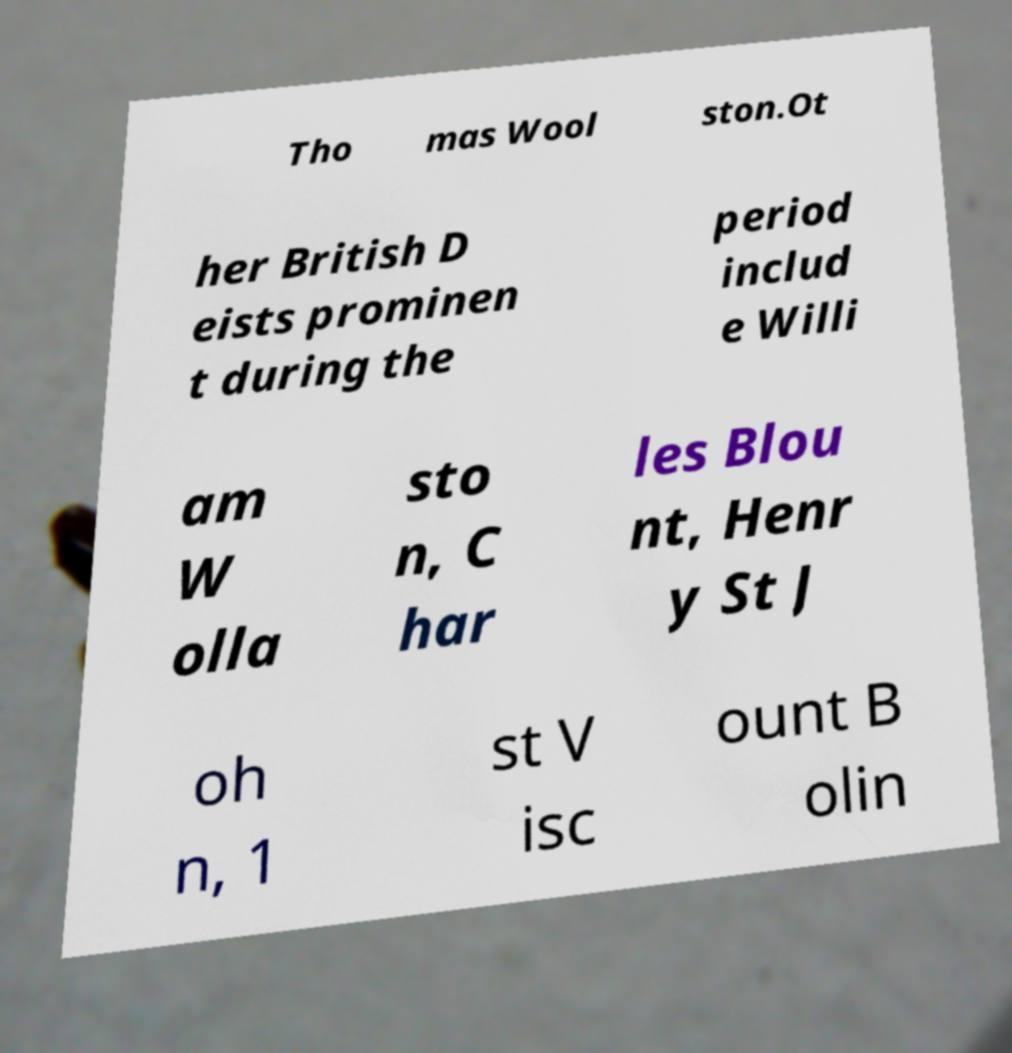I need the written content from this picture converted into text. Can you do that? Tho mas Wool ston.Ot her British D eists prominen t during the period includ e Willi am W olla sto n, C har les Blou nt, Henr y St J oh n, 1 st V isc ount B olin 